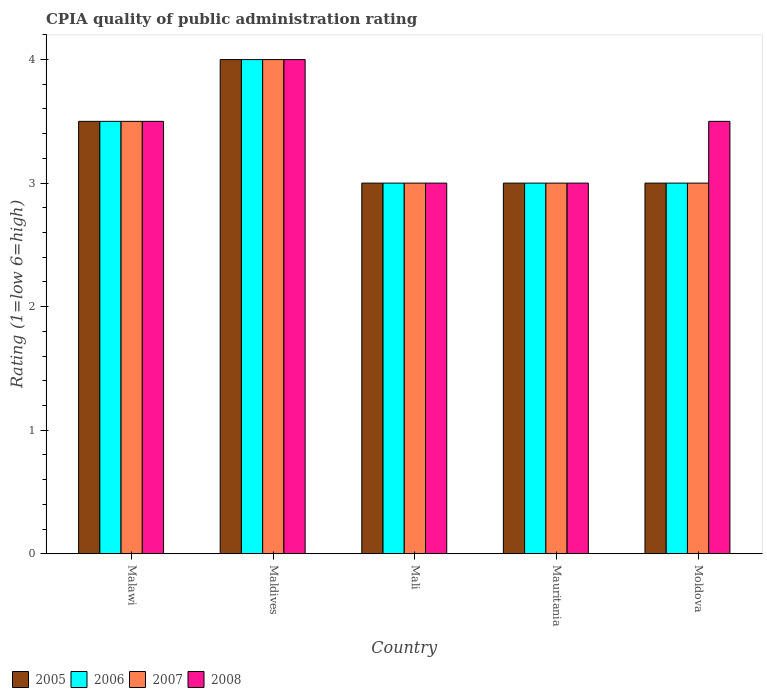How many groups of bars are there?
Provide a short and direct response. 5. Are the number of bars per tick equal to the number of legend labels?
Offer a very short reply. Yes. Are the number of bars on each tick of the X-axis equal?
Give a very brief answer. Yes. What is the label of the 1st group of bars from the left?
Your answer should be compact. Malawi. In how many cases, is the number of bars for a given country not equal to the number of legend labels?
Make the answer very short. 0. In which country was the CPIA rating in 2005 maximum?
Provide a short and direct response. Maldives. In which country was the CPIA rating in 2006 minimum?
Your answer should be very brief. Mali. What is the total CPIA rating in 2006 in the graph?
Your answer should be very brief. 16.5. What is the difference between the CPIA rating in 2005 in Maldives and that in Moldova?
Offer a terse response. 1. What is the difference between the CPIA rating in 2008 in Moldova and the CPIA rating in 2007 in Maldives?
Ensure brevity in your answer.  -0.5. What is the difference between the CPIA rating of/in 2006 and CPIA rating of/in 2007 in Malawi?
Provide a succinct answer. 0. What is the ratio of the CPIA rating in 2008 in Malawi to that in Mali?
Provide a short and direct response. 1.17. What does the 1st bar from the left in Maldives represents?
Give a very brief answer. 2005. Is it the case that in every country, the sum of the CPIA rating in 2005 and CPIA rating in 2006 is greater than the CPIA rating in 2008?
Offer a terse response. Yes. How many bars are there?
Offer a very short reply. 20. Are all the bars in the graph horizontal?
Your response must be concise. No. Are the values on the major ticks of Y-axis written in scientific E-notation?
Offer a terse response. No. Does the graph contain any zero values?
Offer a terse response. No. How are the legend labels stacked?
Keep it short and to the point. Horizontal. What is the title of the graph?
Offer a terse response. CPIA quality of public administration rating. What is the label or title of the X-axis?
Provide a short and direct response. Country. What is the label or title of the Y-axis?
Your answer should be compact. Rating (1=low 6=high). What is the Rating (1=low 6=high) in 2005 in Malawi?
Your response must be concise. 3.5. What is the Rating (1=low 6=high) in 2007 in Malawi?
Ensure brevity in your answer.  3.5. What is the Rating (1=low 6=high) in 2008 in Malawi?
Provide a short and direct response. 3.5. What is the Rating (1=low 6=high) of 2005 in Maldives?
Offer a terse response. 4. What is the Rating (1=low 6=high) of 2007 in Maldives?
Ensure brevity in your answer.  4. What is the Rating (1=low 6=high) of 2005 in Mali?
Offer a terse response. 3. What is the Rating (1=low 6=high) of 2006 in Mali?
Your answer should be very brief. 3. What is the Rating (1=low 6=high) of 2006 in Mauritania?
Offer a terse response. 3. What is the Rating (1=low 6=high) in 2007 in Mauritania?
Offer a terse response. 3. What is the Rating (1=low 6=high) in 2005 in Moldova?
Offer a very short reply. 3. Across all countries, what is the maximum Rating (1=low 6=high) of 2005?
Offer a terse response. 4. Across all countries, what is the maximum Rating (1=low 6=high) of 2006?
Offer a very short reply. 4. Across all countries, what is the maximum Rating (1=low 6=high) in 2007?
Provide a short and direct response. 4. Across all countries, what is the maximum Rating (1=low 6=high) in 2008?
Give a very brief answer. 4. Across all countries, what is the minimum Rating (1=low 6=high) of 2005?
Ensure brevity in your answer.  3. Across all countries, what is the minimum Rating (1=low 6=high) in 2006?
Offer a terse response. 3. Across all countries, what is the minimum Rating (1=low 6=high) of 2008?
Provide a short and direct response. 3. What is the total Rating (1=low 6=high) in 2005 in the graph?
Your answer should be compact. 16.5. What is the difference between the Rating (1=low 6=high) in 2006 in Malawi and that in Maldives?
Provide a succinct answer. -0.5. What is the difference between the Rating (1=low 6=high) of 2008 in Malawi and that in Maldives?
Offer a very short reply. -0.5. What is the difference between the Rating (1=low 6=high) of 2005 in Malawi and that in Mali?
Provide a succinct answer. 0.5. What is the difference between the Rating (1=low 6=high) of 2006 in Malawi and that in Mali?
Your answer should be very brief. 0.5. What is the difference between the Rating (1=low 6=high) of 2006 in Malawi and that in Mauritania?
Make the answer very short. 0.5. What is the difference between the Rating (1=low 6=high) of 2007 in Malawi and that in Mauritania?
Give a very brief answer. 0.5. What is the difference between the Rating (1=low 6=high) of 2008 in Malawi and that in Moldova?
Keep it short and to the point. 0. What is the difference between the Rating (1=low 6=high) in 2005 in Maldives and that in Mali?
Ensure brevity in your answer.  1. What is the difference between the Rating (1=low 6=high) in 2006 in Maldives and that in Mali?
Your response must be concise. 1. What is the difference between the Rating (1=low 6=high) in 2007 in Maldives and that in Mali?
Your response must be concise. 1. What is the difference between the Rating (1=low 6=high) of 2005 in Maldives and that in Mauritania?
Offer a very short reply. 1. What is the difference between the Rating (1=low 6=high) in 2008 in Maldives and that in Mauritania?
Give a very brief answer. 1. What is the difference between the Rating (1=low 6=high) of 2005 in Maldives and that in Moldova?
Ensure brevity in your answer.  1. What is the difference between the Rating (1=low 6=high) of 2007 in Mali and that in Mauritania?
Your answer should be very brief. 0. What is the difference between the Rating (1=low 6=high) in 2006 in Mali and that in Moldova?
Give a very brief answer. 0. What is the difference between the Rating (1=low 6=high) of 2005 in Mauritania and that in Moldova?
Make the answer very short. 0. What is the difference between the Rating (1=low 6=high) of 2005 in Malawi and the Rating (1=low 6=high) of 2008 in Maldives?
Your response must be concise. -0.5. What is the difference between the Rating (1=low 6=high) in 2006 in Malawi and the Rating (1=low 6=high) in 2007 in Maldives?
Keep it short and to the point. -0.5. What is the difference between the Rating (1=low 6=high) in 2007 in Malawi and the Rating (1=low 6=high) in 2008 in Maldives?
Your answer should be very brief. -0.5. What is the difference between the Rating (1=low 6=high) of 2005 in Malawi and the Rating (1=low 6=high) of 2007 in Mali?
Make the answer very short. 0.5. What is the difference between the Rating (1=low 6=high) of 2005 in Malawi and the Rating (1=low 6=high) of 2008 in Mali?
Provide a succinct answer. 0.5. What is the difference between the Rating (1=low 6=high) in 2006 in Malawi and the Rating (1=low 6=high) in 2008 in Mali?
Your response must be concise. 0.5. What is the difference between the Rating (1=low 6=high) in 2007 in Malawi and the Rating (1=low 6=high) in 2008 in Moldova?
Your response must be concise. 0. What is the difference between the Rating (1=low 6=high) of 2006 in Maldives and the Rating (1=low 6=high) of 2007 in Mali?
Provide a short and direct response. 1. What is the difference between the Rating (1=low 6=high) in 2006 in Maldives and the Rating (1=low 6=high) in 2008 in Mali?
Your answer should be compact. 1. What is the difference between the Rating (1=low 6=high) in 2007 in Maldives and the Rating (1=low 6=high) in 2008 in Mali?
Your answer should be very brief. 1. What is the difference between the Rating (1=low 6=high) in 2005 in Maldives and the Rating (1=low 6=high) in 2006 in Mauritania?
Make the answer very short. 1. What is the difference between the Rating (1=low 6=high) in 2005 in Maldives and the Rating (1=low 6=high) in 2008 in Mauritania?
Give a very brief answer. 1. What is the difference between the Rating (1=low 6=high) in 2006 in Maldives and the Rating (1=low 6=high) in 2007 in Mauritania?
Make the answer very short. 1. What is the difference between the Rating (1=low 6=high) of 2006 in Maldives and the Rating (1=low 6=high) of 2008 in Mauritania?
Make the answer very short. 1. What is the difference between the Rating (1=low 6=high) of 2007 in Maldives and the Rating (1=low 6=high) of 2008 in Mauritania?
Offer a terse response. 1. What is the difference between the Rating (1=low 6=high) of 2005 in Maldives and the Rating (1=low 6=high) of 2006 in Moldova?
Your answer should be very brief. 1. What is the difference between the Rating (1=low 6=high) of 2006 in Maldives and the Rating (1=low 6=high) of 2007 in Moldova?
Ensure brevity in your answer.  1. What is the difference between the Rating (1=low 6=high) of 2006 in Maldives and the Rating (1=low 6=high) of 2008 in Moldova?
Give a very brief answer. 0.5. What is the difference between the Rating (1=low 6=high) of 2005 in Mali and the Rating (1=low 6=high) of 2008 in Mauritania?
Your answer should be compact. 0. What is the difference between the Rating (1=low 6=high) in 2007 in Mali and the Rating (1=low 6=high) in 2008 in Mauritania?
Provide a succinct answer. 0. What is the difference between the Rating (1=low 6=high) in 2005 in Mali and the Rating (1=low 6=high) in 2006 in Moldova?
Offer a terse response. 0. What is the difference between the Rating (1=low 6=high) of 2005 in Mali and the Rating (1=low 6=high) of 2007 in Moldova?
Your response must be concise. 0. What is the difference between the Rating (1=low 6=high) in 2005 in Mali and the Rating (1=low 6=high) in 2008 in Moldova?
Your answer should be very brief. -0.5. What is the difference between the Rating (1=low 6=high) of 2007 in Mali and the Rating (1=low 6=high) of 2008 in Moldova?
Provide a short and direct response. -0.5. What is the difference between the Rating (1=low 6=high) in 2005 in Mauritania and the Rating (1=low 6=high) in 2008 in Moldova?
Your response must be concise. -0.5. What is the average Rating (1=low 6=high) in 2005 per country?
Your answer should be compact. 3.3. What is the average Rating (1=low 6=high) in 2007 per country?
Your response must be concise. 3.3. What is the average Rating (1=low 6=high) of 2008 per country?
Make the answer very short. 3.4. What is the difference between the Rating (1=low 6=high) in 2005 and Rating (1=low 6=high) in 2006 in Malawi?
Your answer should be very brief. 0. What is the difference between the Rating (1=low 6=high) of 2005 and Rating (1=low 6=high) of 2007 in Malawi?
Make the answer very short. 0. What is the difference between the Rating (1=low 6=high) of 2005 and Rating (1=low 6=high) of 2008 in Malawi?
Give a very brief answer. 0. What is the difference between the Rating (1=low 6=high) of 2006 and Rating (1=low 6=high) of 2007 in Malawi?
Provide a short and direct response. 0. What is the difference between the Rating (1=low 6=high) in 2005 and Rating (1=low 6=high) in 2006 in Maldives?
Ensure brevity in your answer.  0. What is the difference between the Rating (1=low 6=high) of 2005 and Rating (1=low 6=high) of 2008 in Maldives?
Your answer should be very brief. 0. What is the difference between the Rating (1=low 6=high) of 2006 and Rating (1=low 6=high) of 2008 in Maldives?
Offer a very short reply. 0. What is the difference between the Rating (1=low 6=high) in 2007 and Rating (1=low 6=high) in 2008 in Maldives?
Offer a very short reply. 0. What is the difference between the Rating (1=low 6=high) of 2005 and Rating (1=low 6=high) of 2006 in Mali?
Give a very brief answer. 0. What is the difference between the Rating (1=low 6=high) of 2006 and Rating (1=low 6=high) of 2008 in Mali?
Keep it short and to the point. 0. What is the difference between the Rating (1=low 6=high) in 2007 and Rating (1=low 6=high) in 2008 in Mali?
Your answer should be very brief. 0. What is the difference between the Rating (1=low 6=high) of 2005 and Rating (1=low 6=high) of 2006 in Mauritania?
Your answer should be compact. 0. What is the difference between the Rating (1=low 6=high) in 2006 and Rating (1=low 6=high) in 2007 in Mauritania?
Provide a succinct answer. 0. What is the difference between the Rating (1=low 6=high) in 2005 and Rating (1=low 6=high) in 2006 in Moldova?
Keep it short and to the point. 0. What is the difference between the Rating (1=low 6=high) in 2006 and Rating (1=low 6=high) in 2008 in Moldova?
Ensure brevity in your answer.  -0.5. What is the difference between the Rating (1=low 6=high) of 2007 and Rating (1=low 6=high) of 2008 in Moldova?
Ensure brevity in your answer.  -0.5. What is the ratio of the Rating (1=low 6=high) in 2007 in Malawi to that in Maldives?
Give a very brief answer. 0.88. What is the ratio of the Rating (1=low 6=high) of 2006 in Malawi to that in Mali?
Give a very brief answer. 1.17. What is the ratio of the Rating (1=low 6=high) in 2007 in Malawi to that in Mali?
Your answer should be compact. 1.17. What is the ratio of the Rating (1=low 6=high) in 2005 in Malawi to that in Mauritania?
Give a very brief answer. 1.17. What is the ratio of the Rating (1=low 6=high) in 2006 in Malawi to that in Mauritania?
Your answer should be very brief. 1.17. What is the ratio of the Rating (1=low 6=high) in 2007 in Malawi to that in Mauritania?
Provide a short and direct response. 1.17. What is the ratio of the Rating (1=low 6=high) in 2005 in Malawi to that in Moldova?
Provide a short and direct response. 1.17. What is the ratio of the Rating (1=low 6=high) of 2005 in Maldives to that in Mali?
Provide a succinct answer. 1.33. What is the ratio of the Rating (1=low 6=high) in 2007 in Maldives to that in Mali?
Provide a short and direct response. 1.33. What is the ratio of the Rating (1=low 6=high) in 2008 in Maldives to that in Mali?
Provide a succinct answer. 1.33. What is the ratio of the Rating (1=low 6=high) of 2006 in Maldives to that in Mauritania?
Provide a short and direct response. 1.33. What is the ratio of the Rating (1=low 6=high) of 2008 in Maldives to that in Mauritania?
Give a very brief answer. 1.33. What is the ratio of the Rating (1=low 6=high) of 2007 in Maldives to that in Moldova?
Provide a short and direct response. 1.33. What is the ratio of the Rating (1=low 6=high) of 2007 in Mali to that in Mauritania?
Make the answer very short. 1. What is the ratio of the Rating (1=low 6=high) in 2005 in Mali to that in Moldova?
Offer a terse response. 1. What is the ratio of the Rating (1=low 6=high) in 2006 in Mali to that in Moldova?
Give a very brief answer. 1. What is the ratio of the Rating (1=low 6=high) in 2005 in Mauritania to that in Moldova?
Provide a succinct answer. 1. What is the ratio of the Rating (1=low 6=high) in 2006 in Mauritania to that in Moldova?
Your answer should be compact. 1. What is the difference between the highest and the second highest Rating (1=low 6=high) in 2005?
Your response must be concise. 0.5. What is the difference between the highest and the second highest Rating (1=low 6=high) in 2008?
Keep it short and to the point. 0.5. What is the difference between the highest and the lowest Rating (1=low 6=high) in 2005?
Your answer should be very brief. 1. What is the difference between the highest and the lowest Rating (1=low 6=high) of 2006?
Ensure brevity in your answer.  1. What is the difference between the highest and the lowest Rating (1=low 6=high) in 2007?
Your answer should be very brief. 1. 